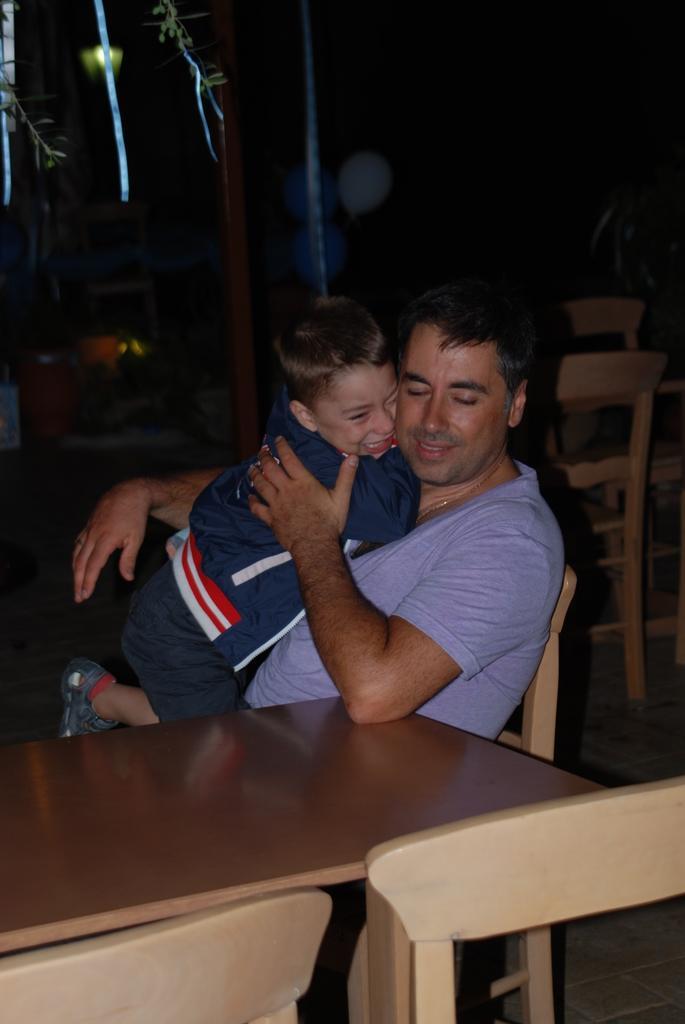Please provide a concise description of this image. There is a man. He is sitting on the chair. He is holding a boy. Besides this person, there is a table and chairs. In the background, there are chairs, balloons, pole and light. 